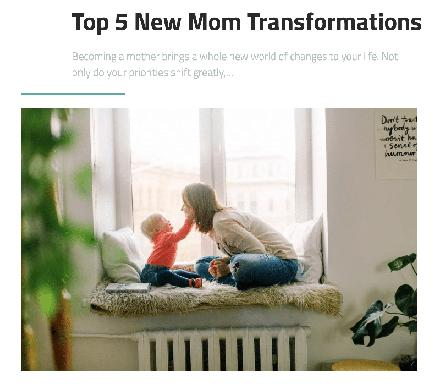How does the image visually represent the concept of new motherhood? The image captures the essence of new motherhood through its serene setting, where a mother and her child are intimately interacting on a window sill. The natural light and soft colors contribute to a peaceful atmosphere, symbolizing the new, nurturing bond and the gentle shift in the mother's world revolving around her child. 